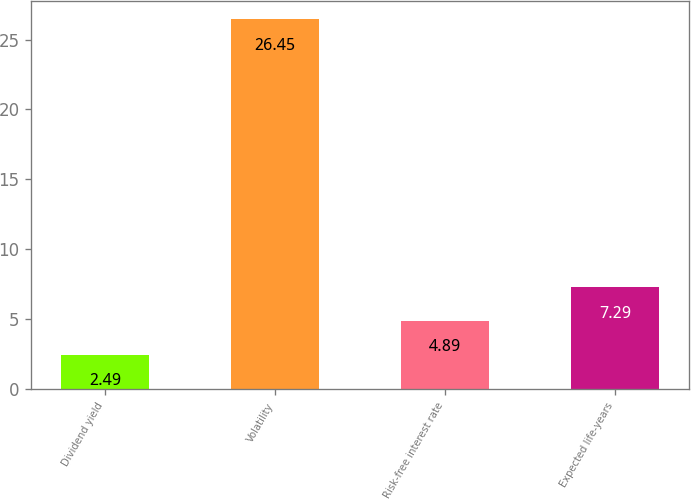Convert chart. <chart><loc_0><loc_0><loc_500><loc_500><bar_chart><fcel>Dividend yield<fcel>Volatility<fcel>Risk-free interest rate<fcel>Expected life-years<nl><fcel>2.49<fcel>26.45<fcel>4.89<fcel>7.29<nl></chart> 